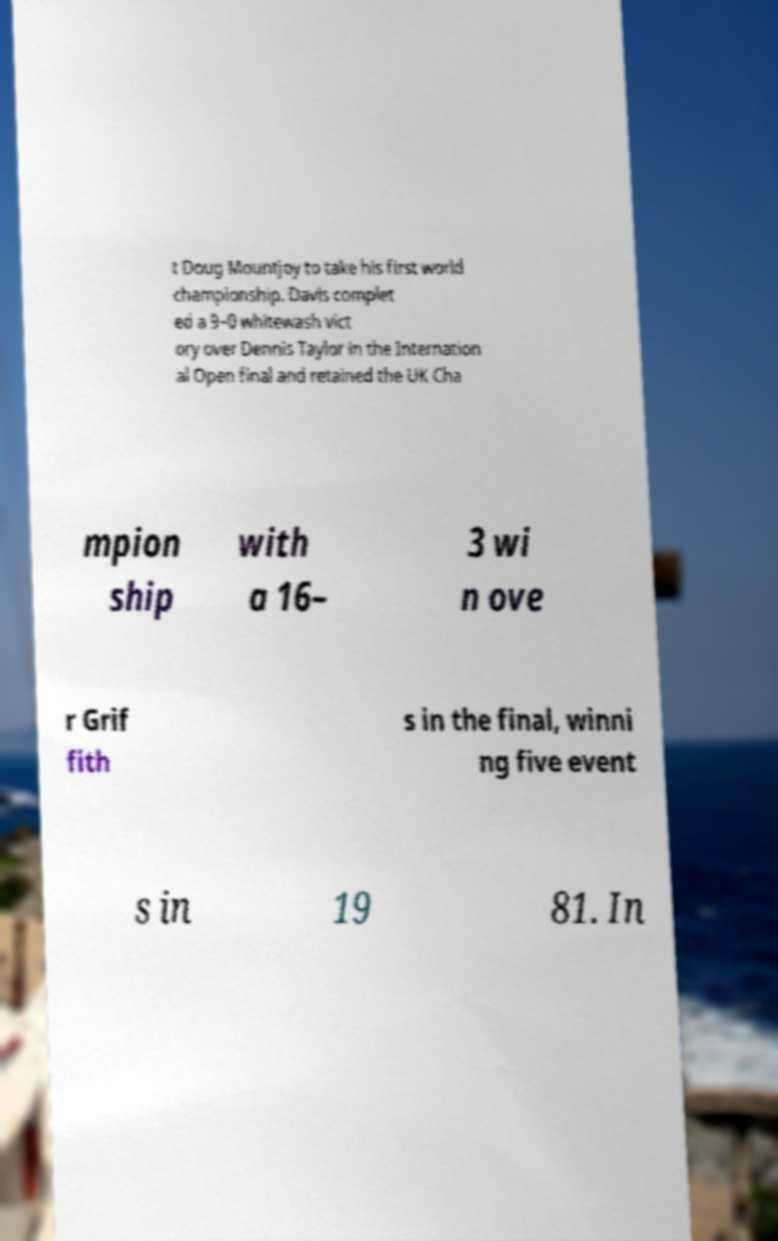Can you accurately transcribe the text from the provided image for me? t Doug Mountjoy to take his first world championship. Davis complet ed a 9–0 whitewash vict ory over Dennis Taylor in the Internation al Open final and retained the UK Cha mpion ship with a 16– 3 wi n ove r Grif fith s in the final, winni ng five event s in 19 81. In 